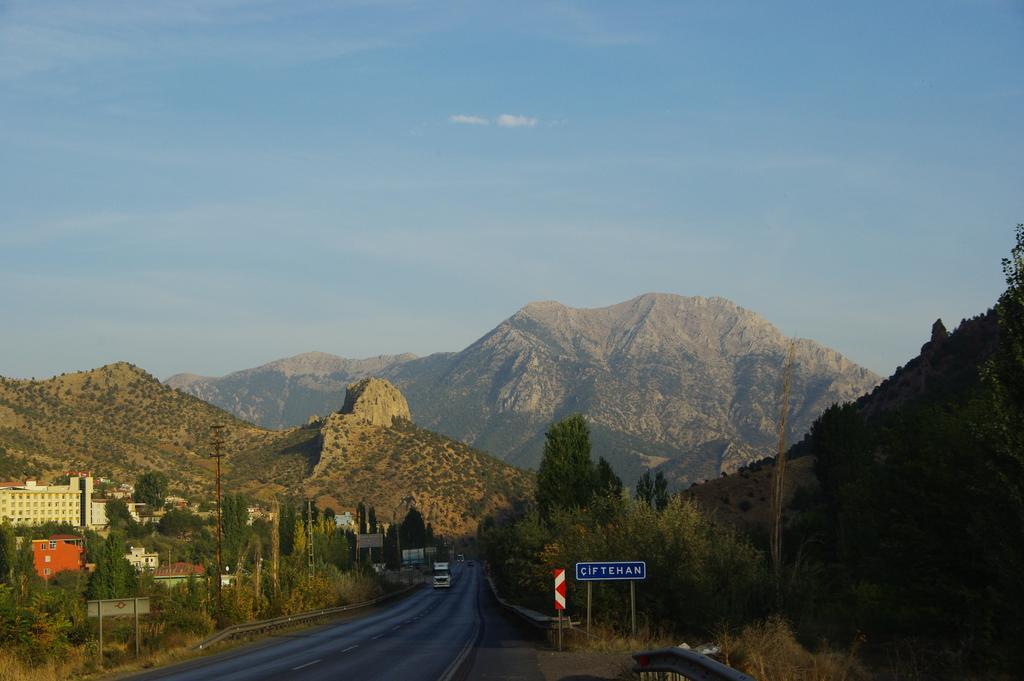Could you give a brief overview of what you see in this image? In the image we can see a vehicle on the road. There is a road, board, electric pole, mountain and a pale blue color sky, we can see there are even buildings. 